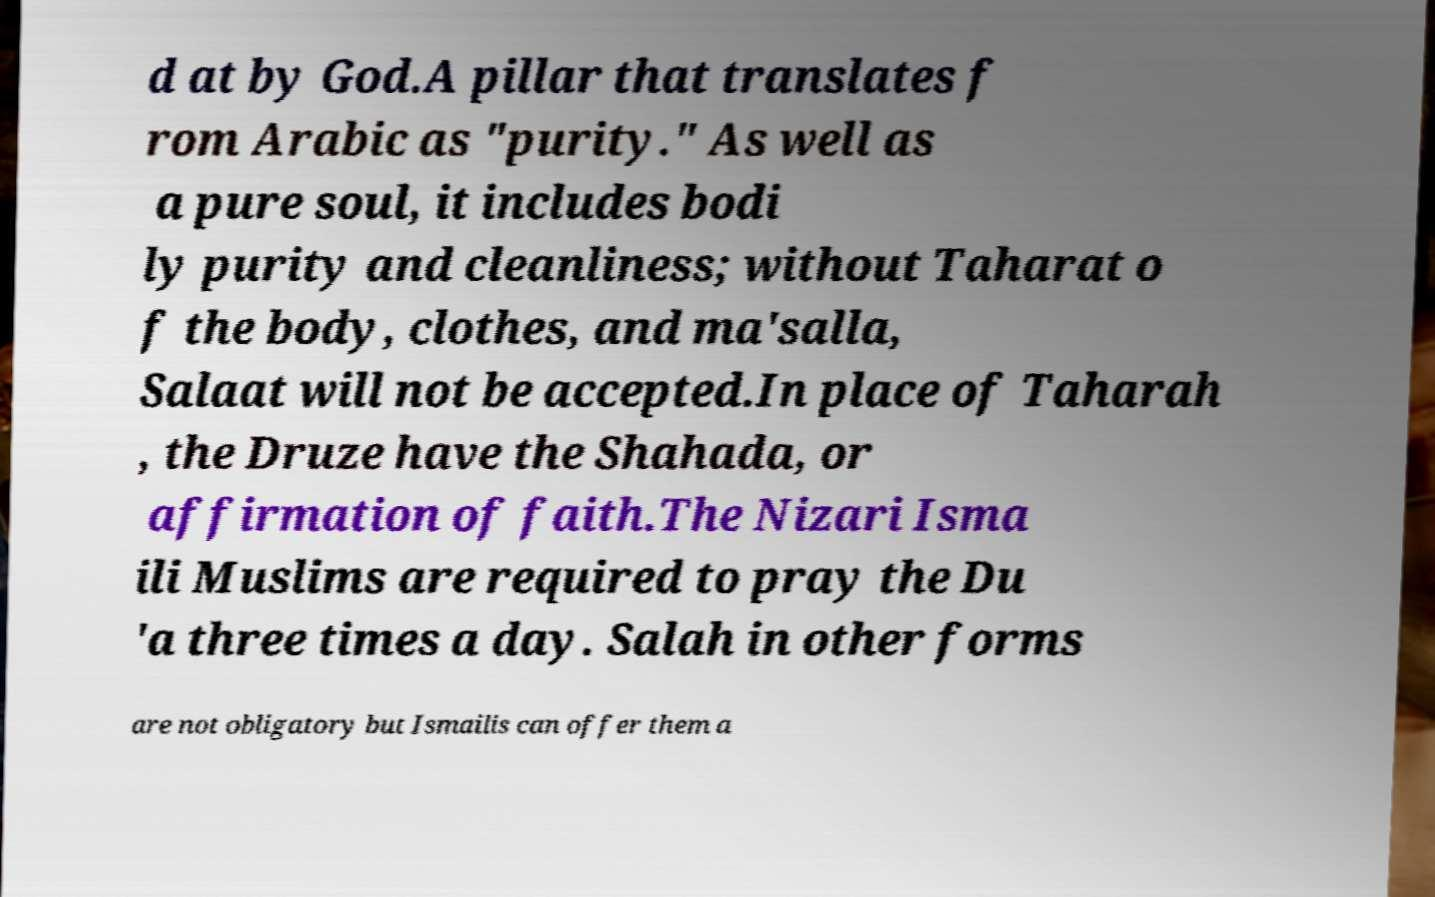For documentation purposes, I need the text within this image transcribed. Could you provide that? d at by God.A pillar that translates f rom Arabic as "purity." As well as a pure soul, it includes bodi ly purity and cleanliness; without Taharat o f the body, clothes, and ma'salla, Salaat will not be accepted.In place of Taharah , the Druze have the Shahada, or affirmation of faith.The Nizari Isma ili Muslims are required to pray the Du 'a three times a day. Salah in other forms are not obligatory but Ismailis can offer them a 